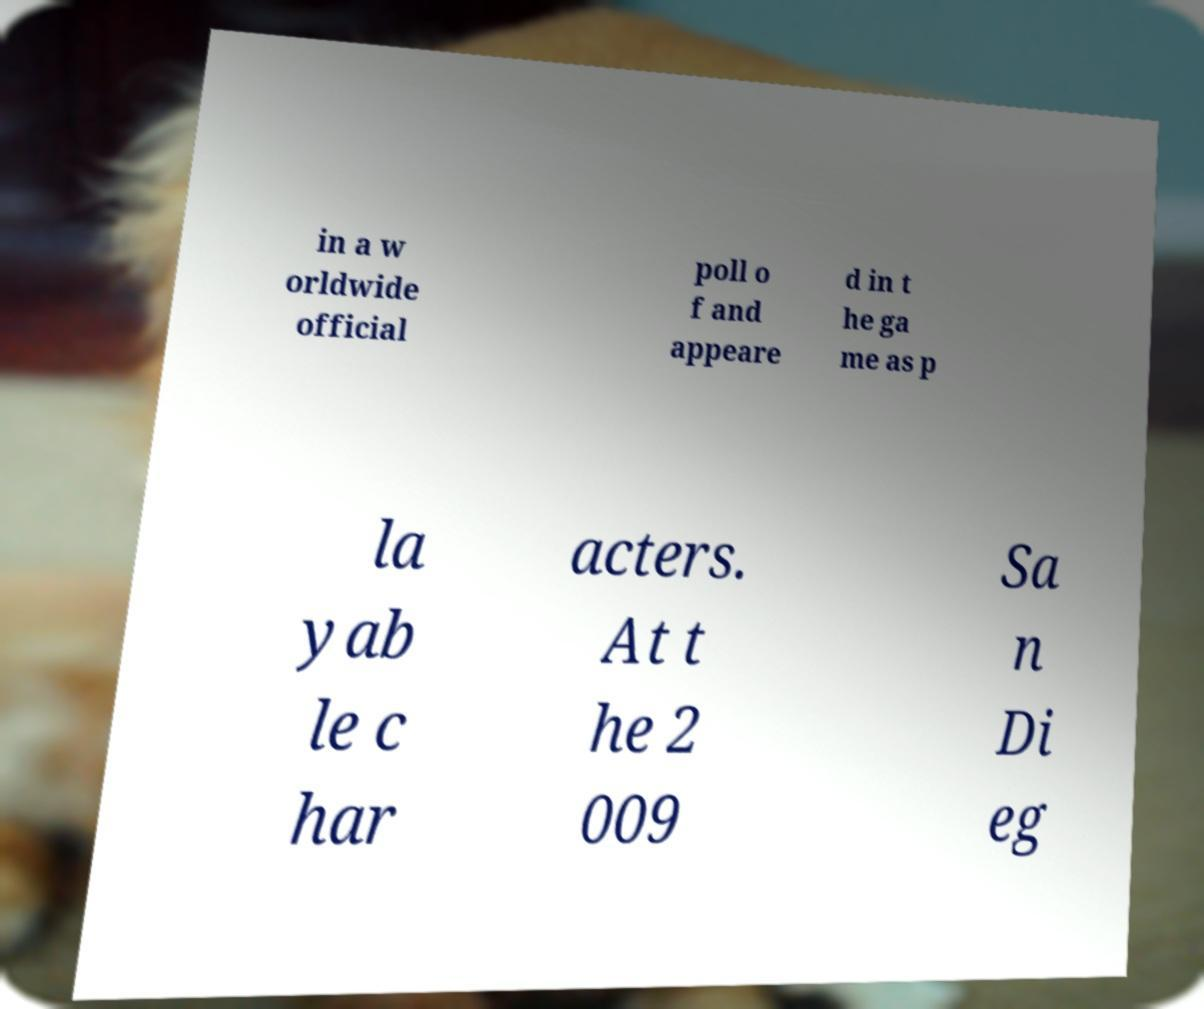There's text embedded in this image that I need extracted. Can you transcribe it verbatim? in a w orldwide official poll o f and appeare d in t he ga me as p la yab le c har acters. At t he 2 009 Sa n Di eg 